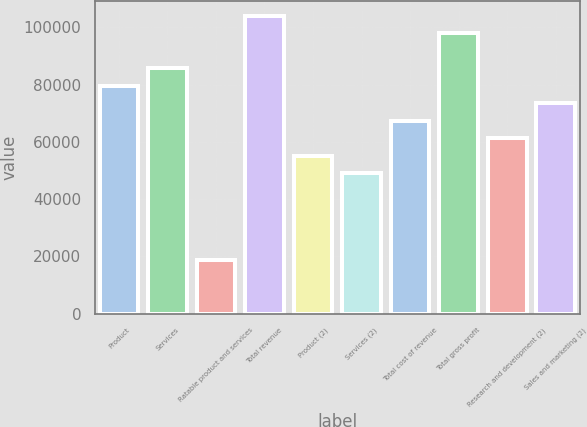Convert chart to OTSL. <chart><loc_0><loc_0><loc_500><loc_500><bar_chart><fcel>Product<fcel>Services<fcel>Ratable product and services<fcel>Total revenue<fcel>Product (2)<fcel>Services (2)<fcel>Total cost of revenue<fcel>Total gross profit<fcel>Research and development (2)<fcel>Sales and marketing (2)<nl><fcel>79663.9<fcel>85770.2<fcel>18600.9<fcel>104089<fcel>55238.7<fcel>49132.4<fcel>67451.3<fcel>97982.8<fcel>61345<fcel>73557.6<nl></chart> 